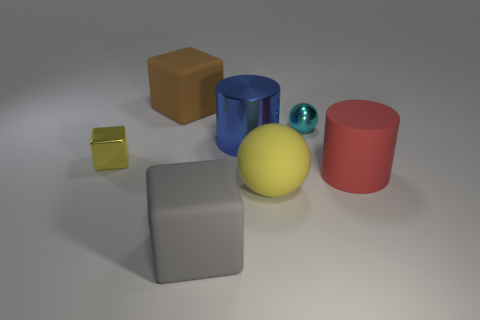There is a blue cylinder that is made of the same material as the tiny yellow cube; what is its size?
Provide a succinct answer. Large. There is a sphere that is the same material as the large gray thing; what is its color?
Offer a very short reply. Yellow. Are there any other yellow things that have the same size as the yellow shiny thing?
Give a very brief answer. No. There is another large red thing that is the same shape as the big metal thing; what material is it?
Your answer should be very brief. Rubber. There is a yellow thing that is the same size as the metallic ball; what is its shape?
Give a very brief answer. Cube. Are there any red things that have the same shape as the large blue object?
Provide a succinct answer. Yes. What shape is the large rubber thing that is right of the small thing on the right side of the brown rubber thing?
Your response must be concise. Cylinder. What is the shape of the big yellow rubber object?
Your response must be concise. Sphere. The cube that is behind the small object that is on the left side of the yellow object that is in front of the red rubber thing is made of what material?
Your response must be concise. Rubber. How many other things are made of the same material as the small cube?
Give a very brief answer. 2. 